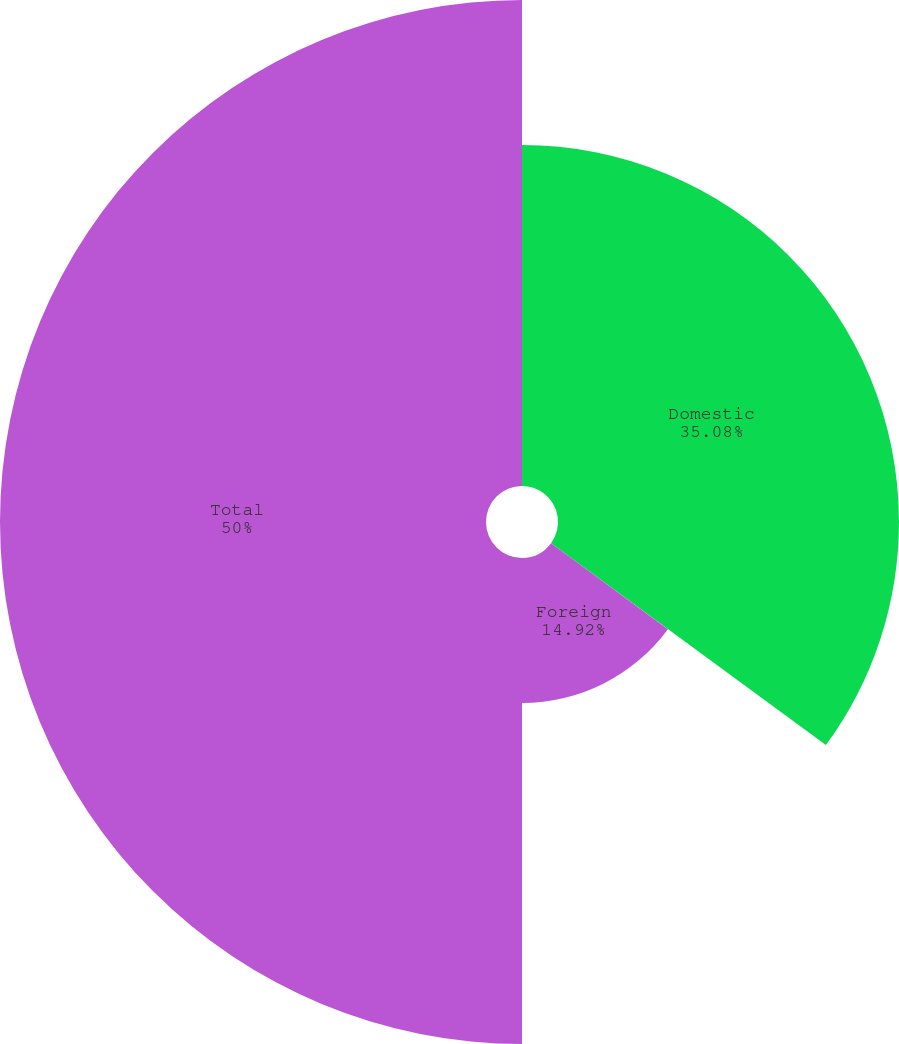Convert chart. <chart><loc_0><loc_0><loc_500><loc_500><pie_chart><fcel>Domestic<fcel>Foreign<fcel>Total<nl><fcel>35.08%<fcel>14.92%<fcel>50.0%<nl></chart> 